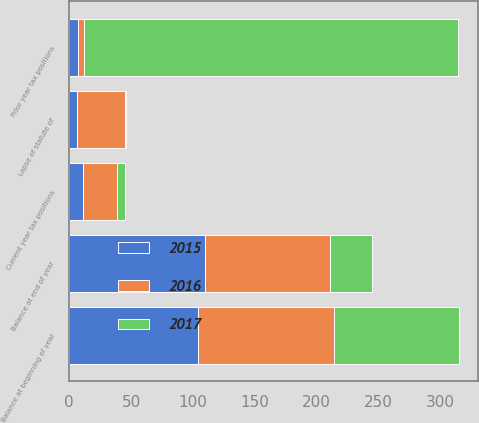<chart> <loc_0><loc_0><loc_500><loc_500><stacked_bar_chart><ecel><fcel>Balance at beginning of year<fcel>Prior year tax positions<fcel>Current year tax positions<fcel>Lapse of statute of<fcel>Balance at end of year<nl><fcel>2017<fcel>101<fcel>302<fcel>6<fcel>1<fcel>33.5<nl><fcel>2016<fcel>110<fcel>5<fcel>28<fcel>39<fcel>101<nl><fcel>2015<fcel>104<fcel>7<fcel>11<fcel>6<fcel>110<nl></chart> 